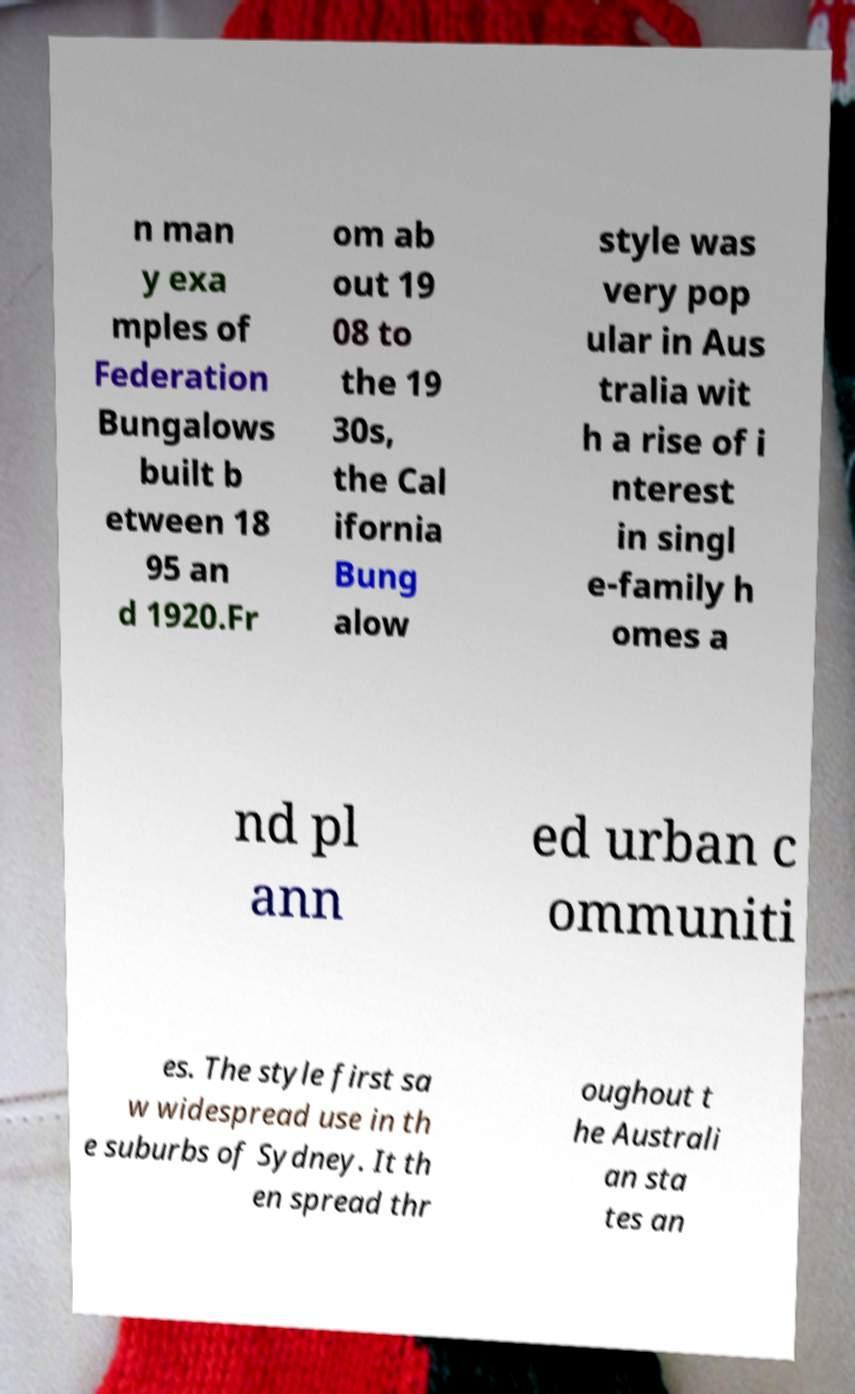For documentation purposes, I need the text within this image transcribed. Could you provide that? n man y exa mples of Federation Bungalows built b etween 18 95 an d 1920.Fr om ab out 19 08 to the 19 30s, the Cal ifornia Bung alow style was very pop ular in Aus tralia wit h a rise of i nterest in singl e-family h omes a nd pl ann ed urban c ommuniti es. The style first sa w widespread use in th e suburbs of Sydney. It th en spread thr oughout t he Australi an sta tes an 